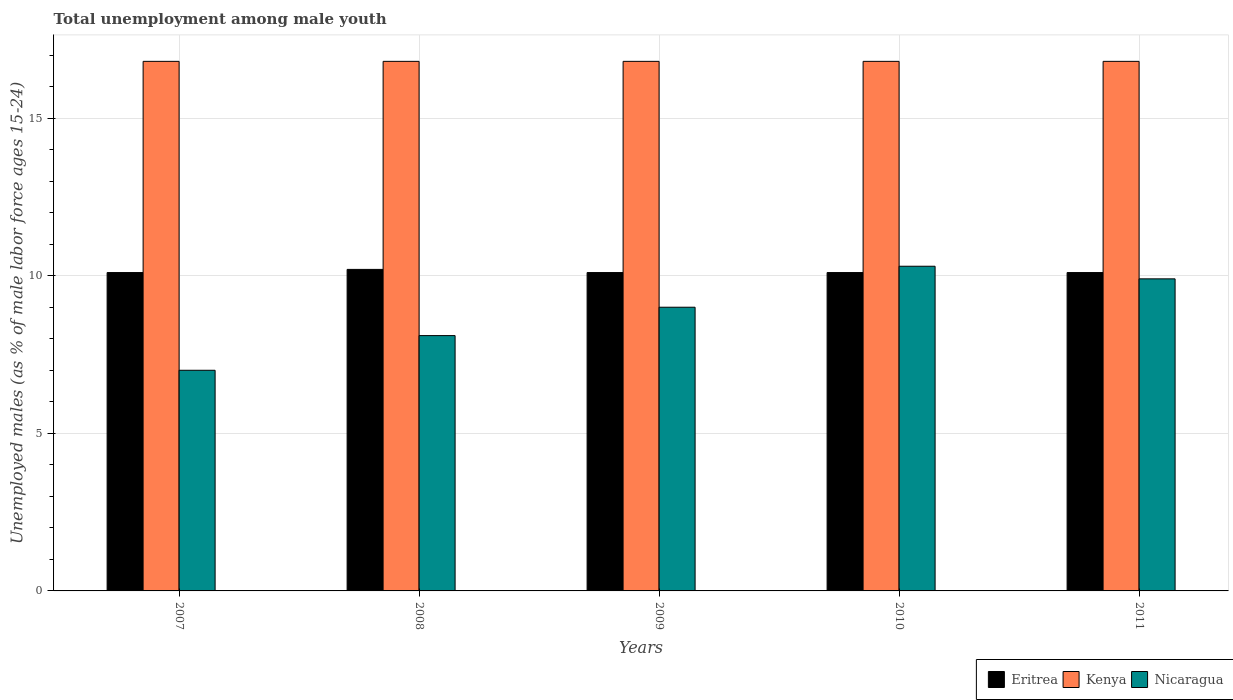How many different coloured bars are there?
Make the answer very short. 3. What is the label of the 1st group of bars from the left?
Make the answer very short. 2007. What is the percentage of unemployed males in in Eritrea in 2011?
Give a very brief answer. 10.1. Across all years, what is the maximum percentage of unemployed males in in Kenya?
Your response must be concise. 16.8. Across all years, what is the minimum percentage of unemployed males in in Eritrea?
Your response must be concise. 10.1. What is the total percentage of unemployed males in in Kenya in the graph?
Your response must be concise. 84. What is the difference between the percentage of unemployed males in in Kenya in 2008 and the percentage of unemployed males in in Nicaragua in 2009?
Offer a very short reply. 7.8. What is the average percentage of unemployed males in in Eritrea per year?
Provide a succinct answer. 10.12. In the year 2008, what is the difference between the percentage of unemployed males in in Kenya and percentage of unemployed males in in Nicaragua?
Your answer should be very brief. 8.7. Is the percentage of unemployed males in in Eritrea in 2009 less than that in 2010?
Offer a very short reply. No. What is the difference between the highest and the second highest percentage of unemployed males in in Nicaragua?
Offer a terse response. 0.4. What is the difference between the highest and the lowest percentage of unemployed males in in Nicaragua?
Provide a succinct answer. 3.3. In how many years, is the percentage of unemployed males in in Nicaragua greater than the average percentage of unemployed males in in Nicaragua taken over all years?
Provide a succinct answer. 3. What does the 1st bar from the left in 2011 represents?
Offer a terse response. Eritrea. What does the 1st bar from the right in 2007 represents?
Give a very brief answer. Nicaragua. What is the difference between two consecutive major ticks on the Y-axis?
Your response must be concise. 5. Are the values on the major ticks of Y-axis written in scientific E-notation?
Offer a terse response. No. Does the graph contain grids?
Provide a short and direct response. Yes. Where does the legend appear in the graph?
Provide a succinct answer. Bottom right. How many legend labels are there?
Your answer should be very brief. 3. How are the legend labels stacked?
Keep it short and to the point. Horizontal. What is the title of the graph?
Keep it short and to the point. Total unemployment among male youth. Does "Liberia" appear as one of the legend labels in the graph?
Offer a very short reply. No. What is the label or title of the Y-axis?
Provide a short and direct response. Unemployed males (as % of male labor force ages 15-24). What is the Unemployed males (as % of male labor force ages 15-24) in Eritrea in 2007?
Ensure brevity in your answer.  10.1. What is the Unemployed males (as % of male labor force ages 15-24) of Kenya in 2007?
Your answer should be very brief. 16.8. What is the Unemployed males (as % of male labor force ages 15-24) in Nicaragua in 2007?
Give a very brief answer. 7. What is the Unemployed males (as % of male labor force ages 15-24) of Eritrea in 2008?
Your response must be concise. 10.2. What is the Unemployed males (as % of male labor force ages 15-24) of Kenya in 2008?
Ensure brevity in your answer.  16.8. What is the Unemployed males (as % of male labor force ages 15-24) of Nicaragua in 2008?
Provide a short and direct response. 8.1. What is the Unemployed males (as % of male labor force ages 15-24) in Eritrea in 2009?
Your answer should be compact. 10.1. What is the Unemployed males (as % of male labor force ages 15-24) in Kenya in 2009?
Your answer should be very brief. 16.8. What is the Unemployed males (as % of male labor force ages 15-24) of Nicaragua in 2009?
Provide a short and direct response. 9. What is the Unemployed males (as % of male labor force ages 15-24) in Eritrea in 2010?
Keep it short and to the point. 10.1. What is the Unemployed males (as % of male labor force ages 15-24) in Kenya in 2010?
Your answer should be compact. 16.8. What is the Unemployed males (as % of male labor force ages 15-24) in Nicaragua in 2010?
Keep it short and to the point. 10.3. What is the Unemployed males (as % of male labor force ages 15-24) in Eritrea in 2011?
Provide a short and direct response. 10.1. What is the Unemployed males (as % of male labor force ages 15-24) of Kenya in 2011?
Your response must be concise. 16.8. What is the Unemployed males (as % of male labor force ages 15-24) of Nicaragua in 2011?
Your answer should be compact. 9.9. Across all years, what is the maximum Unemployed males (as % of male labor force ages 15-24) in Eritrea?
Your response must be concise. 10.2. Across all years, what is the maximum Unemployed males (as % of male labor force ages 15-24) in Kenya?
Keep it short and to the point. 16.8. Across all years, what is the maximum Unemployed males (as % of male labor force ages 15-24) in Nicaragua?
Keep it short and to the point. 10.3. Across all years, what is the minimum Unemployed males (as % of male labor force ages 15-24) in Eritrea?
Provide a short and direct response. 10.1. Across all years, what is the minimum Unemployed males (as % of male labor force ages 15-24) in Kenya?
Your answer should be compact. 16.8. What is the total Unemployed males (as % of male labor force ages 15-24) in Eritrea in the graph?
Ensure brevity in your answer.  50.6. What is the total Unemployed males (as % of male labor force ages 15-24) of Nicaragua in the graph?
Offer a terse response. 44.3. What is the difference between the Unemployed males (as % of male labor force ages 15-24) of Nicaragua in 2007 and that in 2010?
Your answer should be compact. -3.3. What is the difference between the Unemployed males (as % of male labor force ages 15-24) of Eritrea in 2007 and that in 2011?
Make the answer very short. 0. What is the difference between the Unemployed males (as % of male labor force ages 15-24) of Kenya in 2007 and that in 2011?
Offer a very short reply. 0. What is the difference between the Unemployed males (as % of male labor force ages 15-24) in Nicaragua in 2007 and that in 2011?
Keep it short and to the point. -2.9. What is the difference between the Unemployed males (as % of male labor force ages 15-24) in Eritrea in 2008 and that in 2009?
Offer a very short reply. 0.1. What is the difference between the Unemployed males (as % of male labor force ages 15-24) of Nicaragua in 2008 and that in 2009?
Give a very brief answer. -0.9. What is the difference between the Unemployed males (as % of male labor force ages 15-24) in Eritrea in 2008 and that in 2011?
Ensure brevity in your answer.  0.1. What is the difference between the Unemployed males (as % of male labor force ages 15-24) in Eritrea in 2009 and that in 2010?
Make the answer very short. 0. What is the difference between the Unemployed males (as % of male labor force ages 15-24) of Nicaragua in 2010 and that in 2011?
Your response must be concise. 0.4. What is the difference between the Unemployed males (as % of male labor force ages 15-24) in Eritrea in 2007 and the Unemployed males (as % of male labor force ages 15-24) in Kenya in 2008?
Ensure brevity in your answer.  -6.7. What is the difference between the Unemployed males (as % of male labor force ages 15-24) in Eritrea in 2007 and the Unemployed males (as % of male labor force ages 15-24) in Nicaragua in 2008?
Your answer should be very brief. 2. What is the difference between the Unemployed males (as % of male labor force ages 15-24) in Kenya in 2007 and the Unemployed males (as % of male labor force ages 15-24) in Nicaragua in 2008?
Offer a terse response. 8.7. What is the difference between the Unemployed males (as % of male labor force ages 15-24) of Eritrea in 2007 and the Unemployed males (as % of male labor force ages 15-24) of Kenya in 2009?
Offer a terse response. -6.7. What is the difference between the Unemployed males (as % of male labor force ages 15-24) in Eritrea in 2007 and the Unemployed males (as % of male labor force ages 15-24) in Nicaragua in 2009?
Your answer should be very brief. 1.1. What is the difference between the Unemployed males (as % of male labor force ages 15-24) in Kenya in 2007 and the Unemployed males (as % of male labor force ages 15-24) in Nicaragua in 2009?
Offer a terse response. 7.8. What is the difference between the Unemployed males (as % of male labor force ages 15-24) in Eritrea in 2007 and the Unemployed males (as % of male labor force ages 15-24) in Kenya in 2010?
Ensure brevity in your answer.  -6.7. What is the difference between the Unemployed males (as % of male labor force ages 15-24) of Eritrea in 2007 and the Unemployed males (as % of male labor force ages 15-24) of Nicaragua in 2010?
Give a very brief answer. -0.2. What is the difference between the Unemployed males (as % of male labor force ages 15-24) in Kenya in 2007 and the Unemployed males (as % of male labor force ages 15-24) in Nicaragua in 2010?
Your answer should be compact. 6.5. What is the difference between the Unemployed males (as % of male labor force ages 15-24) of Eritrea in 2007 and the Unemployed males (as % of male labor force ages 15-24) of Kenya in 2011?
Keep it short and to the point. -6.7. What is the difference between the Unemployed males (as % of male labor force ages 15-24) in Kenya in 2007 and the Unemployed males (as % of male labor force ages 15-24) in Nicaragua in 2011?
Offer a terse response. 6.9. What is the difference between the Unemployed males (as % of male labor force ages 15-24) in Kenya in 2008 and the Unemployed males (as % of male labor force ages 15-24) in Nicaragua in 2009?
Give a very brief answer. 7.8. What is the difference between the Unemployed males (as % of male labor force ages 15-24) in Eritrea in 2008 and the Unemployed males (as % of male labor force ages 15-24) in Kenya in 2010?
Offer a terse response. -6.6. What is the difference between the Unemployed males (as % of male labor force ages 15-24) of Eritrea in 2008 and the Unemployed males (as % of male labor force ages 15-24) of Kenya in 2011?
Provide a succinct answer. -6.6. What is the difference between the Unemployed males (as % of male labor force ages 15-24) in Eritrea in 2008 and the Unemployed males (as % of male labor force ages 15-24) in Nicaragua in 2011?
Ensure brevity in your answer.  0.3. What is the difference between the Unemployed males (as % of male labor force ages 15-24) of Kenya in 2008 and the Unemployed males (as % of male labor force ages 15-24) of Nicaragua in 2011?
Your response must be concise. 6.9. What is the difference between the Unemployed males (as % of male labor force ages 15-24) of Eritrea in 2009 and the Unemployed males (as % of male labor force ages 15-24) of Kenya in 2010?
Make the answer very short. -6.7. What is the difference between the Unemployed males (as % of male labor force ages 15-24) of Eritrea in 2009 and the Unemployed males (as % of male labor force ages 15-24) of Kenya in 2011?
Your response must be concise. -6.7. What is the difference between the Unemployed males (as % of male labor force ages 15-24) in Kenya in 2009 and the Unemployed males (as % of male labor force ages 15-24) in Nicaragua in 2011?
Keep it short and to the point. 6.9. What is the difference between the Unemployed males (as % of male labor force ages 15-24) in Eritrea in 2010 and the Unemployed males (as % of male labor force ages 15-24) in Nicaragua in 2011?
Keep it short and to the point. 0.2. What is the difference between the Unemployed males (as % of male labor force ages 15-24) in Kenya in 2010 and the Unemployed males (as % of male labor force ages 15-24) in Nicaragua in 2011?
Provide a short and direct response. 6.9. What is the average Unemployed males (as % of male labor force ages 15-24) in Eritrea per year?
Ensure brevity in your answer.  10.12. What is the average Unemployed males (as % of male labor force ages 15-24) of Nicaragua per year?
Give a very brief answer. 8.86. In the year 2007, what is the difference between the Unemployed males (as % of male labor force ages 15-24) of Eritrea and Unemployed males (as % of male labor force ages 15-24) of Kenya?
Provide a succinct answer. -6.7. In the year 2007, what is the difference between the Unemployed males (as % of male labor force ages 15-24) of Eritrea and Unemployed males (as % of male labor force ages 15-24) of Nicaragua?
Provide a short and direct response. 3.1. In the year 2007, what is the difference between the Unemployed males (as % of male labor force ages 15-24) of Kenya and Unemployed males (as % of male labor force ages 15-24) of Nicaragua?
Provide a succinct answer. 9.8. In the year 2008, what is the difference between the Unemployed males (as % of male labor force ages 15-24) in Eritrea and Unemployed males (as % of male labor force ages 15-24) in Nicaragua?
Give a very brief answer. 2.1. In the year 2008, what is the difference between the Unemployed males (as % of male labor force ages 15-24) in Kenya and Unemployed males (as % of male labor force ages 15-24) in Nicaragua?
Make the answer very short. 8.7. In the year 2009, what is the difference between the Unemployed males (as % of male labor force ages 15-24) in Eritrea and Unemployed males (as % of male labor force ages 15-24) in Kenya?
Provide a short and direct response. -6.7. In the year 2009, what is the difference between the Unemployed males (as % of male labor force ages 15-24) in Eritrea and Unemployed males (as % of male labor force ages 15-24) in Nicaragua?
Your response must be concise. 1.1. In the year 2010, what is the difference between the Unemployed males (as % of male labor force ages 15-24) of Kenya and Unemployed males (as % of male labor force ages 15-24) of Nicaragua?
Offer a very short reply. 6.5. In the year 2011, what is the difference between the Unemployed males (as % of male labor force ages 15-24) of Eritrea and Unemployed males (as % of male labor force ages 15-24) of Kenya?
Ensure brevity in your answer.  -6.7. In the year 2011, what is the difference between the Unemployed males (as % of male labor force ages 15-24) of Eritrea and Unemployed males (as % of male labor force ages 15-24) of Nicaragua?
Offer a terse response. 0.2. What is the ratio of the Unemployed males (as % of male labor force ages 15-24) in Eritrea in 2007 to that in 2008?
Offer a terse response. 0.99. What is the ratio of the Unemployed males (as % of male labor force ages 15-24) of Nicaragua in 2007 to that in 2008?
Offer a terse response. 0.86. What is the ratio of the Unemployed males (as % of male labor force ages 15-24) of Eritrea in 2007 to that in 2010?
Give a very brief answer. 1. What is the ratio of the Unemployed males (as % of male labor force ages 15-24) of Nicaragua in 2007 to that in 2010?
Your answer should be compact. 0.68. What is the ratio of the Unemployed males (as % of male labor force ages 15-24) in Eritrea in 2007 to that in 2011?
Your answer should be very brief. 1. What is the ratio of the Unemployed males (as % of male labor force ages 15-24) in Nicaragua in 2007 to that in 2011?
Your response must be concise. 0.71. What is the ratio of the Unemployed males (as % of male labor force ages 15-24) of Eritrea in 2008 to that in 2009?
Offer a terse response. 1.01. What is the ratio of the Unemployed males (as % of male labor force ages 15-24) of Eritrea in 2008 to that in 2010?
Your answer should be compact. 1.01. What is the ratio of the Unemployed males (as % of male labor force ages 15-24) of Nicaragua in 2008 to that in 2010?
Ensure brevity in your answer.  0.79. What is the ratio of the Unemployed males (as % of male labor force ages 15-24) in Eritrea in 2008 to that in 2011?
Ensure brevity in your answer.  1.01. What is the ratio of the Unemployed males (as % of male labor force ages 15-24) of Kenya in 2008 to that in 2011?
Your response must be concise. 1. What is the ratio of the Unemployed males (as % of male labor force ages 15-24) of Nicaragua in 2008 to that in 2011?
Your answer should be compact. 0.82. What is the ratio of the Unemployed males (as % of male labor force ages 15-24) in Kenya in 2009 to that in 2010?
Offer a terse response. 1. What is the ratio of the Unemployed males (as % of male labor force ages 15-24) of Nicaragua in 2009 to that in 2010?
Ensure brevity in your answer.  0.87. What is the ratio of the Unemployed males (as % of male labor force ages 15-24) of Eritrea in 2009 to that in 2011?
Offer a terse response. 1. What is the ratio of the Unemployed males (as % of male labor force ages 15-24) of Nicaragua in 2009 to that in 2011?
Give a very brief answer. 0.91. What is the ratio of the Unemployed males (as % of male labor force ages 15-24) of Kenya in 2010 to that in 2011?
Your response must be concise. 1. What is the ratio of the Unemployed males (as % of male labor force ages 15-24) of Nicaragua in 2010 to that in 2011?
Make the answer very short. 1.04. What is the difference between the highest and the second highest Unemployed males (as % of male labor force ages 15-24) of Eritrea?
Ensure brevity in your answer.  0.1. What is the difference between the highest and the lowest Unemployed males (as % of male labor force ages 15-24) of Kenya?
Your response must be concise. 0. 